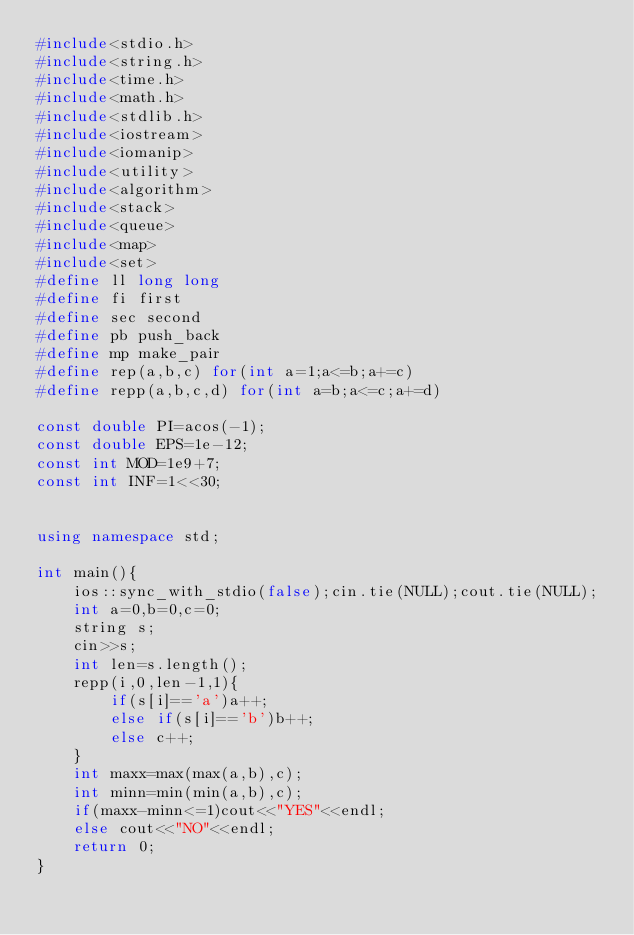Convert code to text. <code><loc_0><loc_0><loc_500><loc_500><_C++_>#include<stdio.h>
#include<string.h>
#include<time.h>
#include<math.h>
#include<stdlib.h>
#include<iostream>
#include<iomanip>
#include<utility>
#include<algorithm>
#include<stack>
#include<queue>
#include<map>
#include<set>
#define ll long long
#define fi first
#define sec second
#define pb push_back
#define mp make_pair
#define rep(a,b,c) for(int a=1;a<=b;a+=c)
#define repp(a,b,c,d) for(int a=b;a<=c;a+=d)

const double PI=acos(-1);
const double EPS=1e-12;
const int MOD=1e9+7;
const int INF=1<<30;


using namespace std;

int main(){
	ios::sync_with_stdio(false);cin.tie(NULL);cout.tie(NULL);
	int a=0,b=0,c=0;
	string s; 
	cin>>s; 
	int len=s.length();
	repp(i,0,len-1,1){
		if(s[i]=='a')a++;
		else if(s[i]=='b')b++;
		else c++;
	}
	int maxx=max(max(a,b),c);
	int minn=min(min(a,b),c);
	if(maxx-minn<=1)cout<<"YES"<<endl; 
	else cout<<"NO"<<endl; 
	return 0;
}

    </code> 